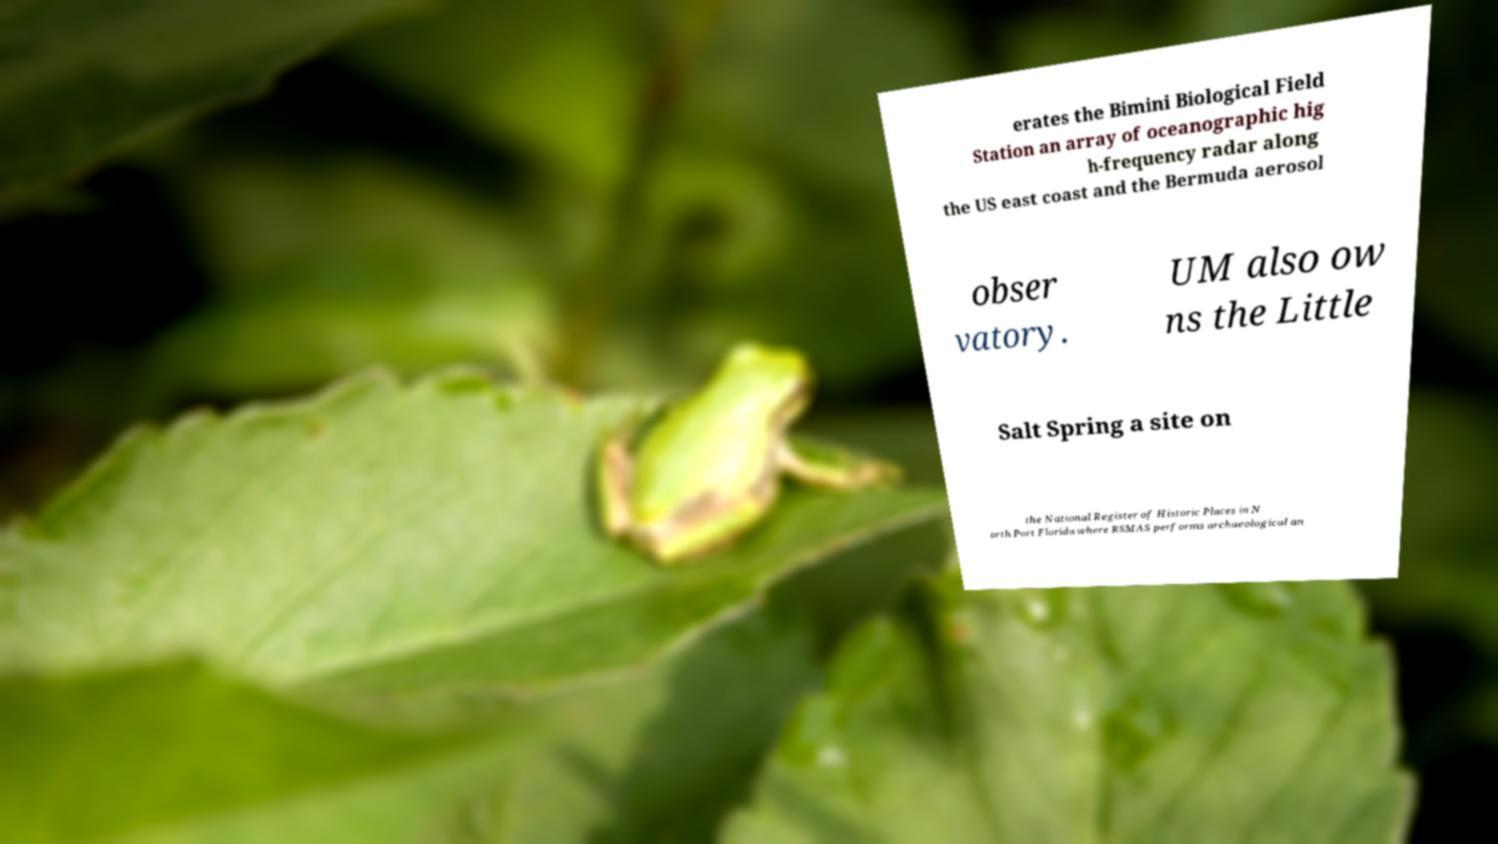There's text embedded in this image that I need extracted. Can you transcribe it verbatim? erates the Bimini Biological Field Station an array of oceanographic hig h-frequency radar along the US east coast and the Bermuda aerosol obser vatory. UM also ow ns the Little Salt Spring a site on the National Register of Historic Places in N orth Port Florida where RSMAS performs archaeological an 